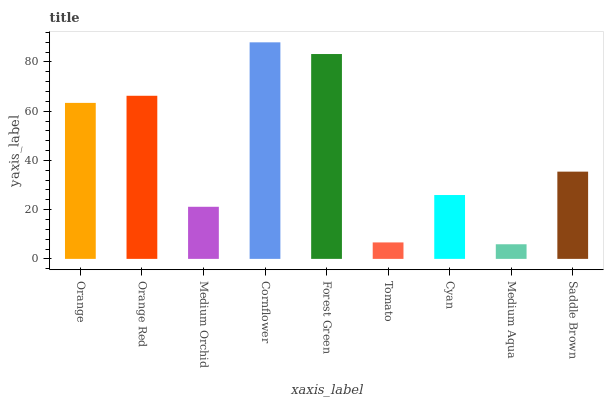Is Medium Aqua the minimum?
Answer yes or no. Yes. Is Cornflower the maximum?
Answer yes or no. Yes. Is Orange Red the minimum?
Answer yes or no. No. Is Orange Red the maximum?
Answer yes or no. No. Is Orange Red greater than Orange?
Answer yes or no. Yes. Is Orange less than Orange Red?
Answer yes or no. Yes. Is Orange greater than Orange Red?
Answer yes or no. No. Is Orange Red less than Orange?
Answer yes or no. No. Is Saddle Brown the high median?
Answer yes or no. Yes. Is Saddle Brown the low median?
Answer yes or no. Yes. Is Medium Orchid the high median?
Answer yes or no. No. Is Forest Green the low median?
Answer yes or no. No. 